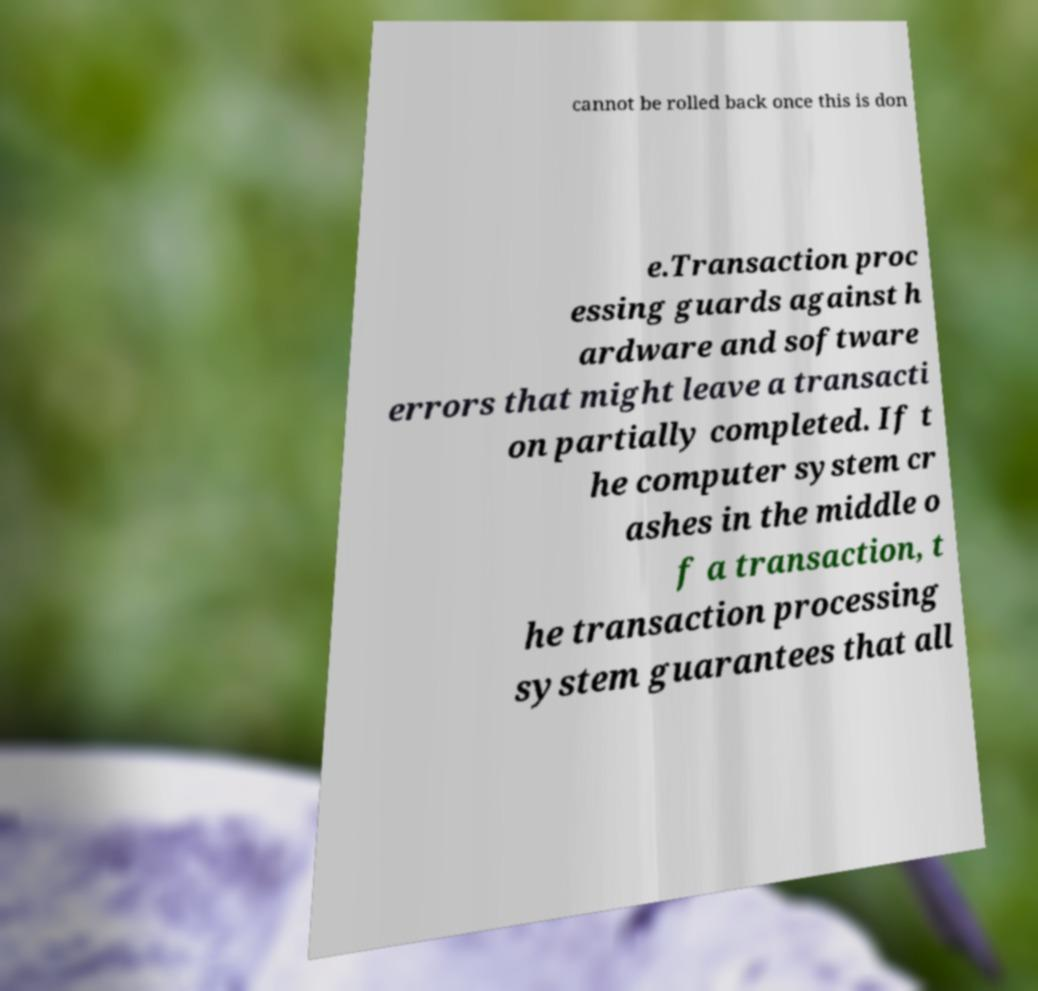Can you read and provide the text displayed in the image?This photo seems to have some interesting text. Can you extract and type it out for me? cannot be rolled back once this is don e.Transaction proc essing guards against h ardware and software errors that might leave a transacti on partially completed. If t he computer system cr ashes in the middle o f a transaction, t he transaction processing system guarantees that all 